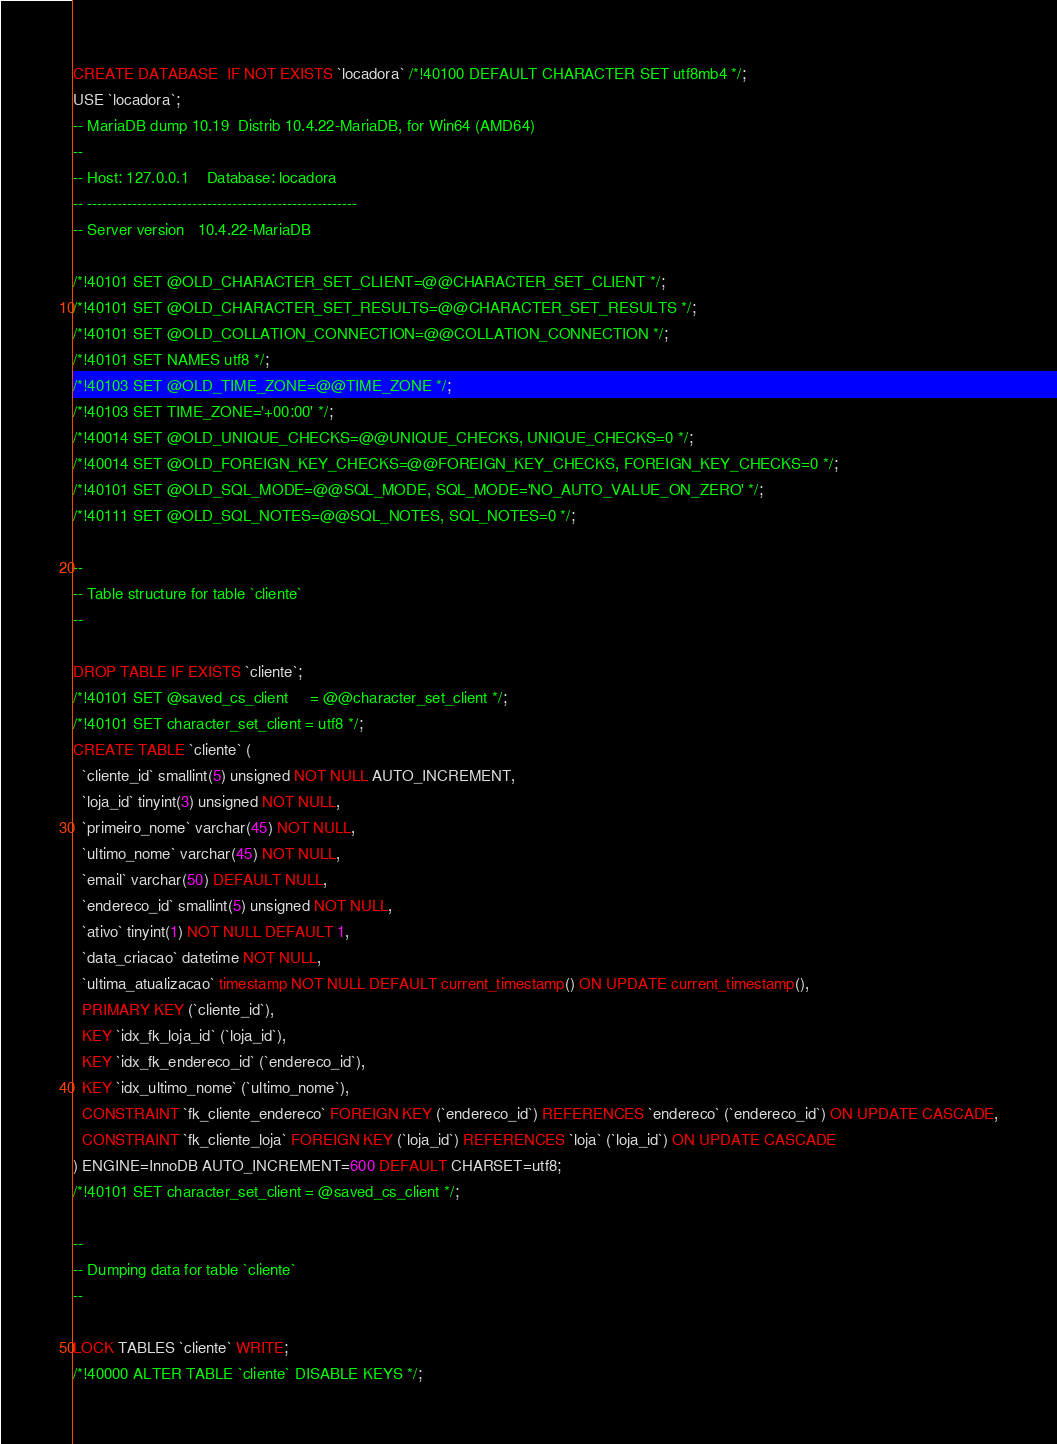<code> <loc_0><loc_0><loc_500><loc_500><_SQL_>CREATE DATABASE  IF NOT EXISTS `locadora` /*!40100 DEFAULT CHARACTER SET utf8mb4 */;
USE `locadora`;
-- MariaDB dump 10.19  Distrib 10.4.22-MariaDB, for Win64 (AMD64)
--
-- Host: 127.0.0.1    Database: locadora
-- ------------------------------------------------------
-- Server version	10.4.22-MariaDB

/*!40101 SET @OLD_CHARACTER_SET_CLIENT=@@CHARACTER_SET_CLIENT */;
/*!40101 SET @OLD_CHARACTER_SET_RESULTS=@@CHARACTER_SET_RESULTS */;
/*!40101 SET @OLD_COLLATION_CONNECTION=@@COLLATION_CONNECTION */;
/*!40101 SET NAMES utf8 */;
/*!40103 SET @OLD_TIME_ZONE=@@TIME_ZONE */;
/*!40103 SET TIME_ZONE='+00:00' */;
/*!40014 SET @OLD_UNIQUE_CHECKS=@@UNIQUE_CHECKS, UNIQUE_CHECKS=0 */;
/*!40014 SET @OLD_FOREIGN_KEY_CHECKS=@@FOREIGN_KEY_CHECKS, FOREIGN_KEY_CHECKS=0 */;
/*!40101 SET @OLD_SQL_MODE=@@SQL_MODE, SQL_MODE='NO_AUTO_VALUE_ON_ZERO' */;
/*!40111 SET @OLD_SQL_NOTES=@@SQL_NOTES, SQL_NOTES=0 */;

--
-- Table structure for table `cliente`
--

DROP TABLE IF EXISTS `cliente`;
/*!40101 SET @saved_cs_client     = @@character_set_client */;
/*!40101 SET character_set_client = utf8 */;
CREATE TABLE `cliente` (
  `cliente_id` smallint(5) unsigned NOT NULL AUTO_INCREMENT,
  `loja_id` tinyint(3) unsigned NOT NULL,
  `primeiro_nome` varchar(45) NOT NULL,
  `ultimo_nome` varchar(45) NOT NULL,
  `email` varchar(50) DEFAULT NULL,
  `endereco_id` smallint(5) unsigned NOT NULL,
  `ativo` tinyint(1) NOT NULL DEFAULT 1,
  `data_criacao` datetime NOT NULL,
  `ultima_atualizacao` timestamp NOT NULL DEFAULT current_timestamp() ON UPDATE current_timestamp(),
  PRIMARY KEY (`cliente_id`),
  KEY `idx_fk_loja_id` (`loja_id`),
  KEY `idx_fk_endereco_id` (`endereco_id`),
  KEY `idx_ultimo_nome` (`ultimo_nome`),
  CONSTRAINT `fk_cliente_endereco` FOREIGN KEY (`endereco_id`) REFERENCES `endereco` (`endereco_id`) ON UPDATE CASCADE,
  CONSTRAINT `fk_cliente_loja` FOREIGN KEY (`loja_id`) REFERENCES `loja` (`loja_id`) ON UPDATE CASCADE
) ENGINE=InnoDB AUTO_INCREMENT=600 DEFAULT CHARSET=utf8;
/*!40101 SET character_set_client = @saved_cs_client */;

--
-- Dumping data for table `cliente`
--

LOCK TABLES `cliente` WRITE;
/*!40000 ALTER TABLE `cliente` DISABLE KEYS */;</code> 